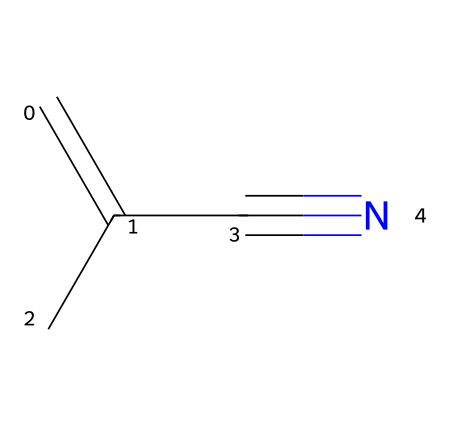What is the name of the chemical with the provided SMILES? The SMILES representation depicts a chemical structure consisting of a carbon-carbon double bond and a nitrile group, which leads to the identification of methacrylonitrile.
Answer: methacrylonitrile How many carbon atoms are present in methacrylonitrile? By analyzing the SMILES notation "C=C(C)C#N", we count three carbon atoms in total: two from the double bond and one from the branching carbon, confirming three carbon atoms.
Answer: three What type of functional group is represented by "C#N" in this structure? The presence of the "C#N" group indicates a nitrile functional group due to the triple bond between carbon and nitrogen, a defining feature of nitriles.
Answer: nitrile What is the hybridization of the carbon atom in the nitrile group? The carbon atom in the nitrile group ("C#N") has a triple bond to nitrogen, which means it is sp hybridized because it forms two sigma bonds and one pi bond.
Answer: sp How many hydrogen atoms are attached to carbon in methacrylonitrile? In the given structure, there is one hydrogen atom on the terminal carbon of the double bond and none on the carbon that connects to the nitrile, leading to a total of three hydrogen atoms.
Answer: three What is the main characteristic of the alkene portion of methacrylonitrile? The alkene portion exhibits a carbon-carbon double bond which contributes to the reactivity of the compound and also affects its physical properties like rigidity and transparency.
Answer: carbon-carbon double bond 